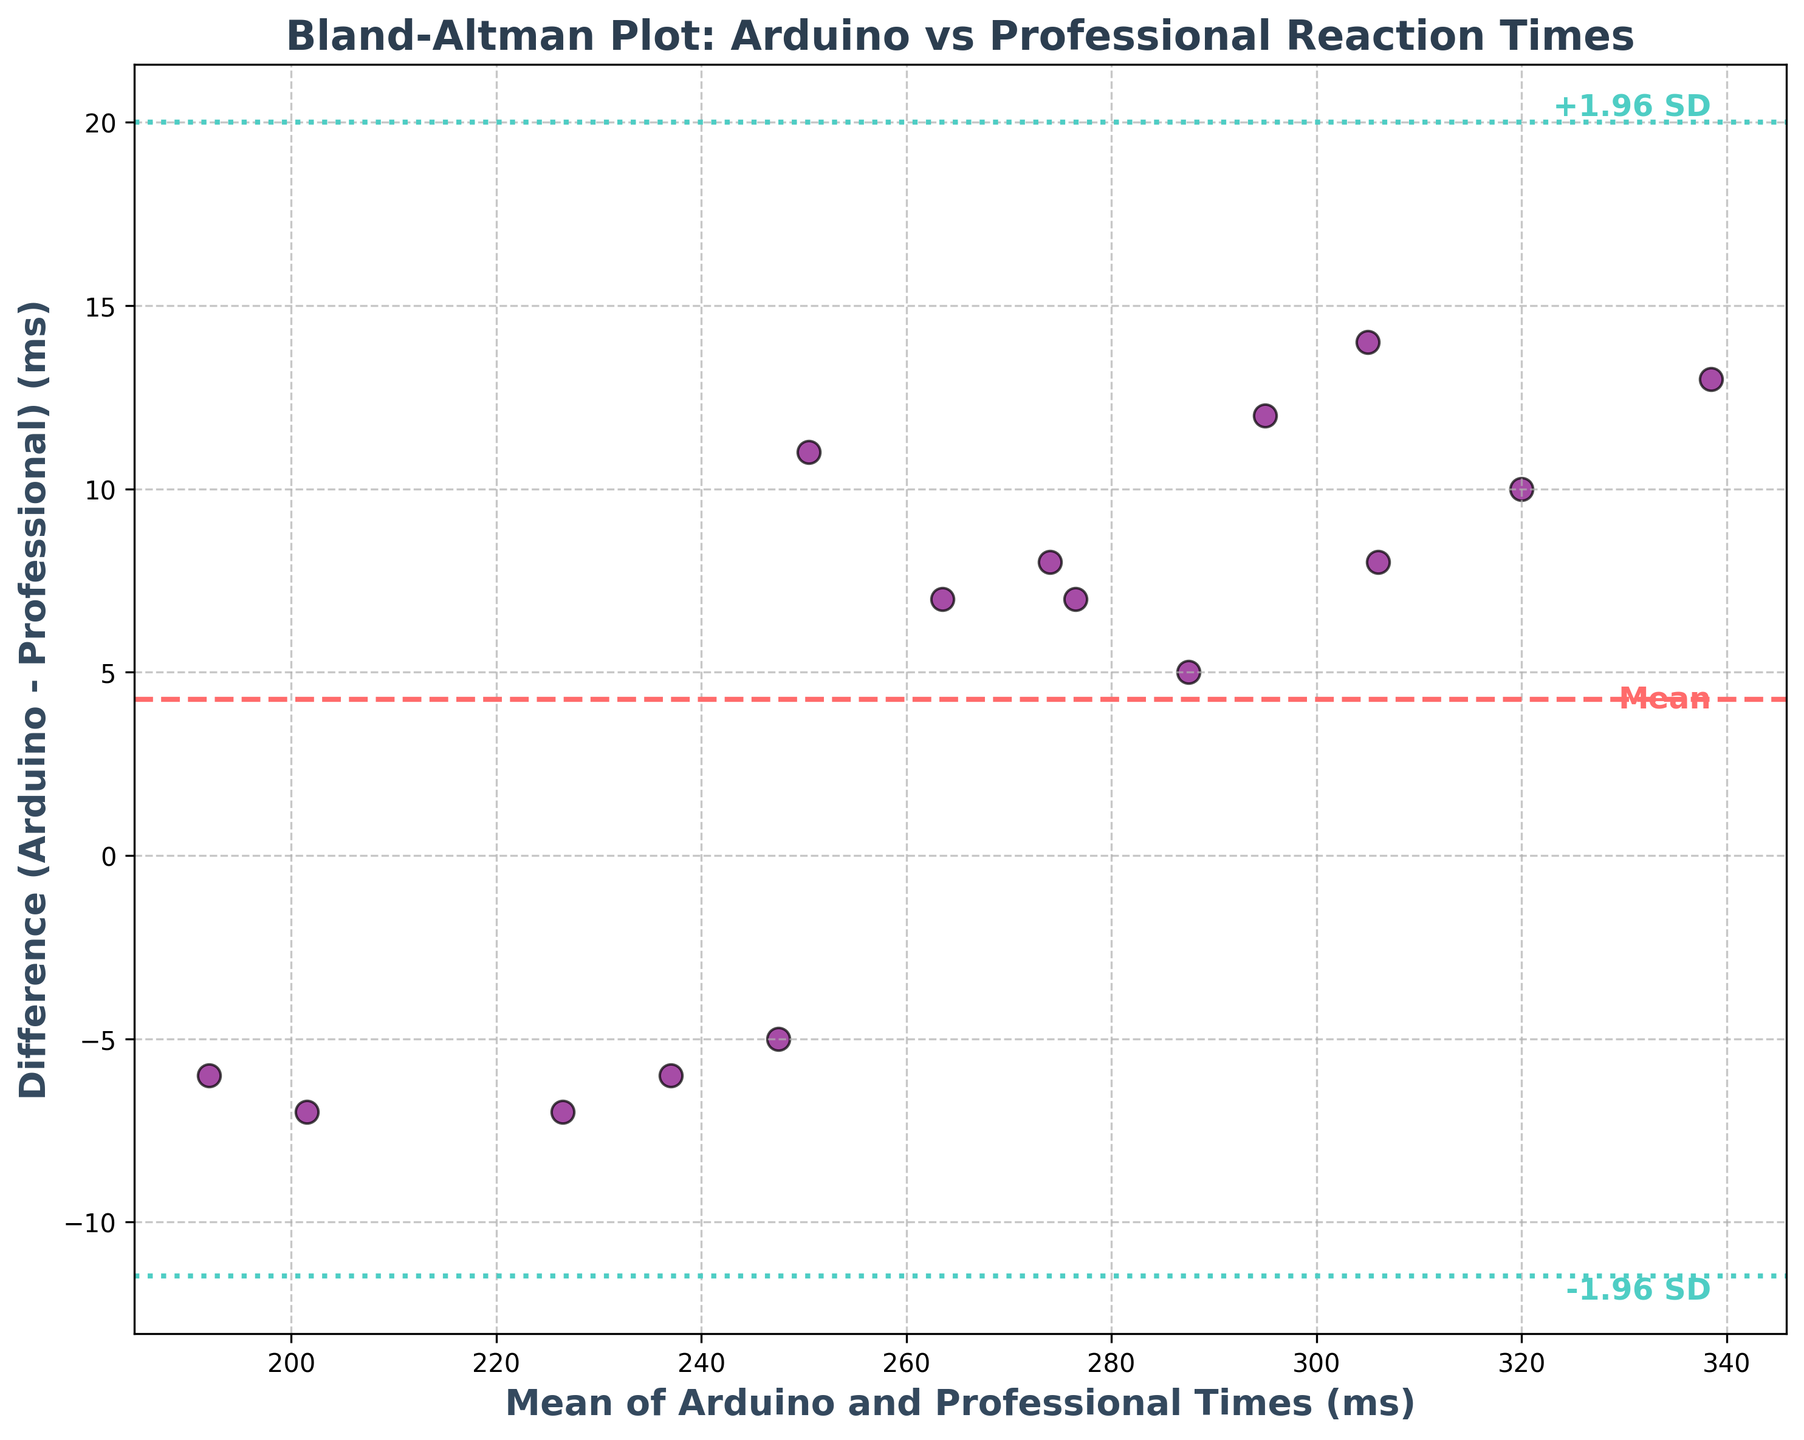How many data points are plotted in the figure? Count the total number of points/grids displayed on the Bland-Altman plot. There is one point for each participant, and there are 15 participants in the data.
Answer: 15 What is the title of the plot? Look at the top of the figure; the title is clearly mentioned.
Answer: Bland-Altman Plot: Arduino vs Professional Reaction Times Which axis represents the mean of Arduino and Professional times? Check the labels of both axes to identify which one represents the mean times. The x-axis shows "Mean of Arduino and Professional Times (ms)."
Answer: x-axis What color is used to plot the differences in times for each participant? Look at the color of the scattered dots on the plot.
Answer: Purple Does the Arduino-based device generally record higher or lower reaction times compared to the professional equipment? To determine this, look at the distribution of points around the mean difference line. Most points are above the zero-difference line. This suggests that the Arduino device generally records higher reaction times.
Answer: Higher What is the mean difference between Arduino and Professional times? The mean difference is indicated by the horizontal dashed line on the plot.
Answer: Approximately 4 ms What do the dotted lines on the plot represent? The dotted lines are the limits of agreement (+/- 1.96 standard deviations from the mean difference). They help understand the spread of differences between devices.
Answer: Limits of agreement What is the range of mean times plotted on the x-axis? Look at the minimum and maximum values on the x-axis.
Answer: Approximately 200 to 340 ms By how much does the point representing Lucas differ from the mean difference line? Find Lucas's point on the plot (mean time around ~338 ms) and measure the vertical distance from the mean difference line (indicated around 13 ms below). The y-coordinate reads around -5 ms (13ms-8ms difference) from the mean line.
Answer: -13 ms Which participant's data shows the largest positive difference between Arduino and Professional times? Identify the highest positive value on the y-axis. The point corresponding to this value has the largest positive difference, around 25ms.
Answer: Lucas 